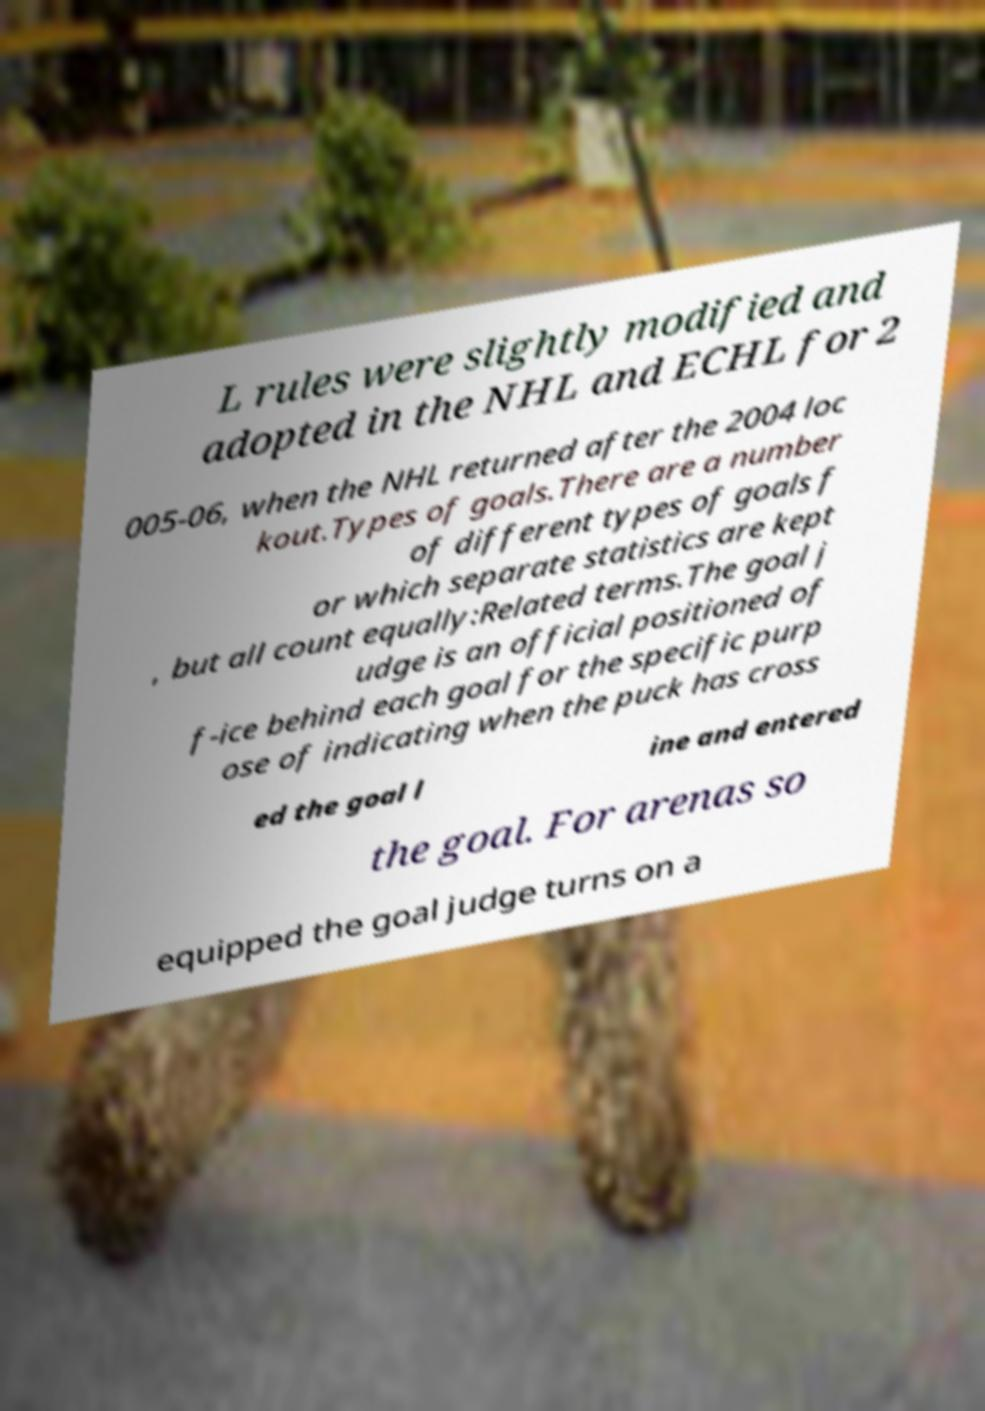Can you accurately transcribe the text from the provided image for me? L rules were slightly modified and adopted in the NHL and ECHL for 2 005-06, when the NHL returned after the 2004 loc kout.Types of goals.There are a number of different types of goals f or which separate statistics are kept , but all count equally:Related terms.The goal j udge is an official positioned of f-ice behind each goal for the specific purp ose of indicating when the puck has cross ed the goal l ine and entered the goal. For arenas so equipped the goal judge turns on a 